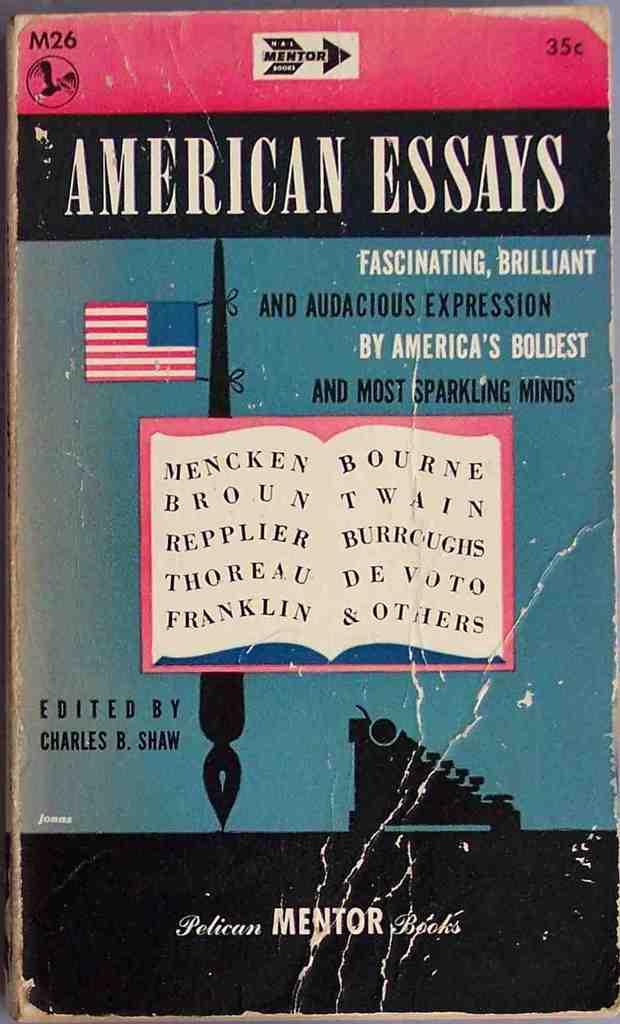<image>
Present a compact description of the photo's key features. a book titles, "American Essays" has a blue cover with an American flag displayed. 